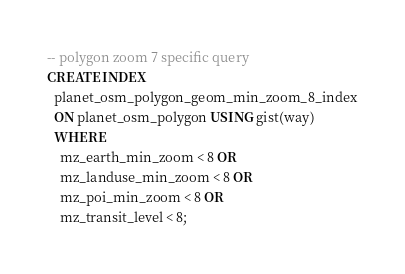Convert code to text. <code><loc_0><loc_0><loc_500><loc_500><_SQL_>-- polygon zoom 7 specific query
CREATE INDEX
  planet_osm_polygon_geom_min_zoom_8_index
  ON planet_osm_polygon USING gist(way)
  WHERE
    mz_earth_min_zoom < 8 OR
    mz_landuse_min_zoom < 8 OR
    mz_poi_min_zoom < 8 OR
    mz_transit_level < 8;
</code> 